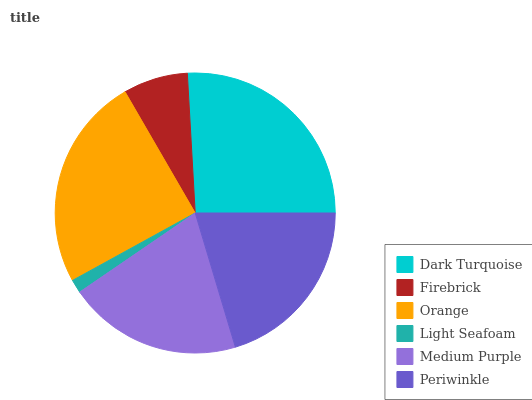Is Light Seafoam the minimum?
Answer yes or no. Yes. Is Dark Turquoise the maximum?
Answer yes or no. Yes. Is Firebrick the minimum?
Answer yes or no. No. Is Firebrick the maximum?
Answer yes or no. No. Is Dark Turquoise greater than Firebrick?
Answer yes or no. Yes. Is Firebrick less than Dark Turquoise?
Answer yes or no. Yes. Is Firebrick greater than Dark Turquoise?
Answer yes or no. No. Is Dark Turquoise less than Firebrick?
Answer yes or no. No. Is Periwinkle the high median?
Answer yes or no. Yes. Is Medium Purple the low median?
Answer yes or no. Yes. Is Firebrick the high median?
Answer yes or no. No. Is Periwinkle the low median?
Answer yes or no. No. 